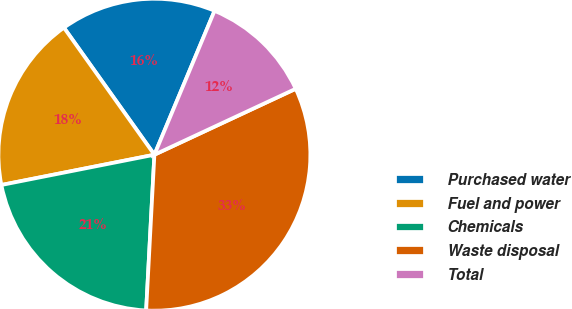Convert chart. <chart><loc_0><loc_0><loc_500><loc_500><pie_chart><fcel>Purchased water<fcel>Fuel and power<fcel>Chemicals<fcel>Waste disposal<fcel>Total<nl><fcel>16.15%<fcel>18.26%<fcel>21.05%<fcel>32.79%<fcel>11.75%<nl></chart> 